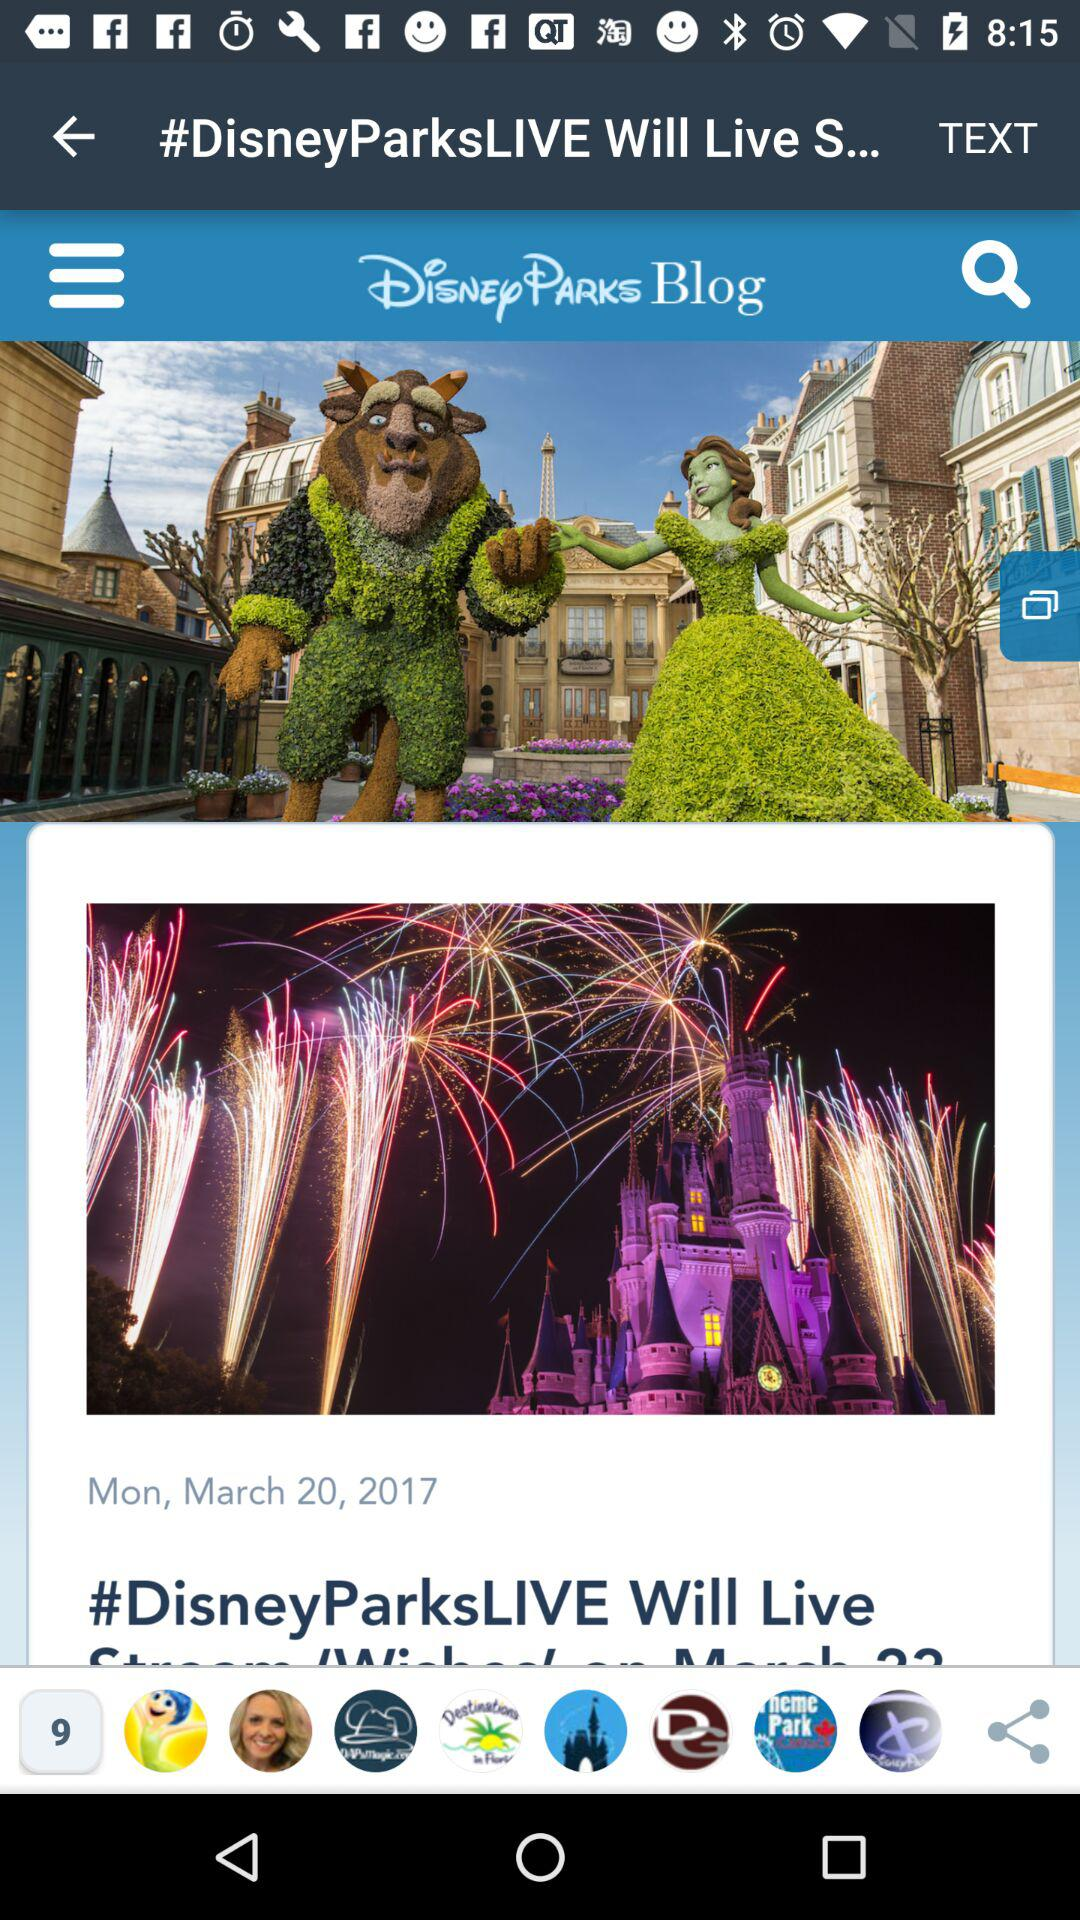What is the date given for "#DisneyParksLIVE"? The date given for "#DisneyParksLIVE" is Monday, March 20, 2017. 